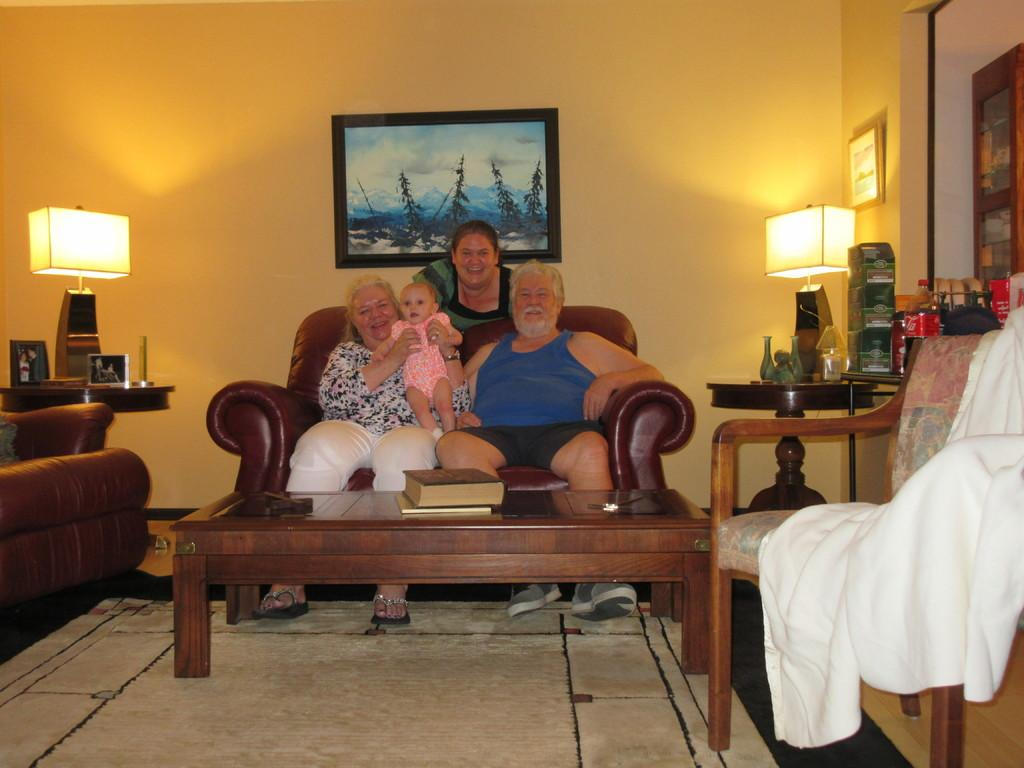Who are the main subjects in the image? There is a couple in the image. What are the couple doing in the image? The couple is posing for a camera. What else can be seen in the image besides the couple? There is a baby sitting on a sofa and a woman standing behind the couple. What type of popcorn is the baby eating in the image? There is no popcorn present in the image; the baby is sitting on a sofa. How many geese are visible in the image? There are no geese present in the image. 